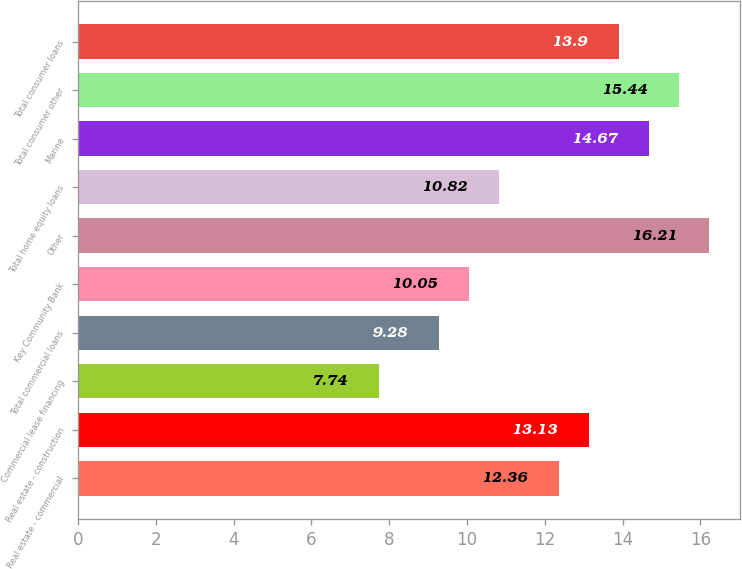Convert chart. <chart><loc_0><loc_0><loc_500><loc_500><bar_chart><fcel>Real estate - commercial<fcel>Real estate - construction<fcel>Commercial lease financing<fcel>Total commercial loans<fcel>Key Community Bank<fcel>Other<fcel>Total home equity loans<fcel>Marine<fcel>Total consumer other<fcel>Total consumer loans<nl><fcel>12.36<fcel>13.13<fcel>7.74<fcel>9.28<fcel>10.05<fcel>16.21<fcel>10.82<fcel>14.67<fcel>15.44<fcel>13.9<nl></chart> 